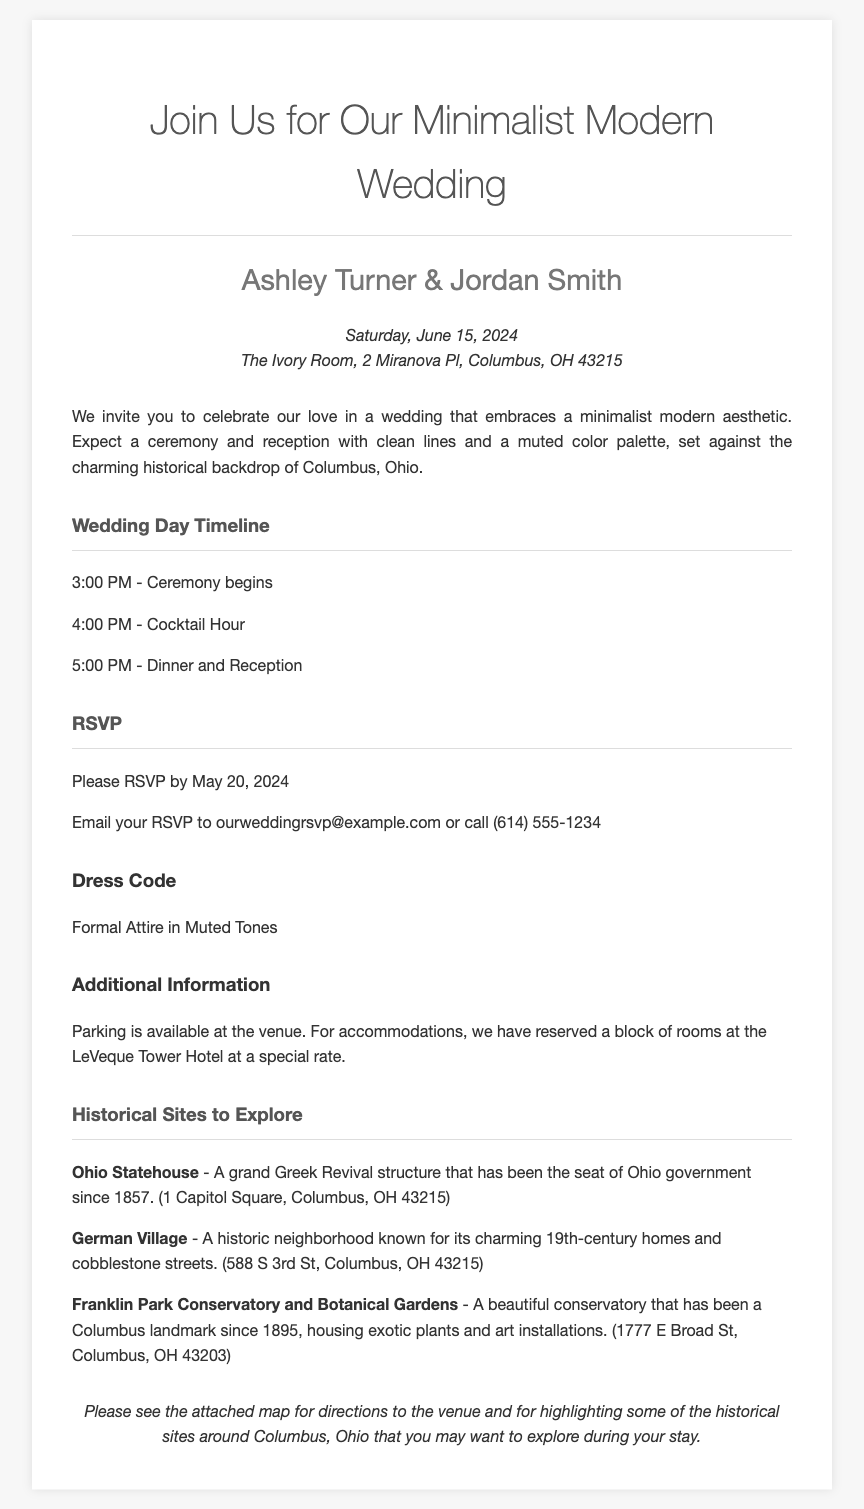What is the date of the wedding? The date of the wedding is mentioned in the document as Saturday, June 15, 2024.
Answer: June 15, 2024 Where is the wedding venue located? The wedding venue is specified in the invitation, which is The Ivory Room at 2 Miranova Pl, Columbus, OH 43215.
Answer: The Ivory Room, 2 Miranova Pl, Columbus, OH 43215 What is the dress code for the wedding? The document clearly states the dress code as Formal Attire in Muted Tones.
Answer: Formal Attire in Muted Tones What time does the ceremony start? The timeline indicates that the ceremony begins at 3:00 PM on the wedding day.
Answer: 3:00 PM How many historical sites are listed? There are three historical sites mentioned in the document for guests to explore.
Answer: Three What is the RSVP deadline? The deadline for RSVPs is noted in the document as May 20, 2024.
Answer: May 20, 2024 What type of ambiance does the wedding embrace? The invitation describes the wedding ambiance as a minimalist modern aesthetic.
Answer: Minimalist modern aesthetic What should guests do to RSVP? The document provides instructions for RSVPing either by email or phone.
Answer: Email or call 